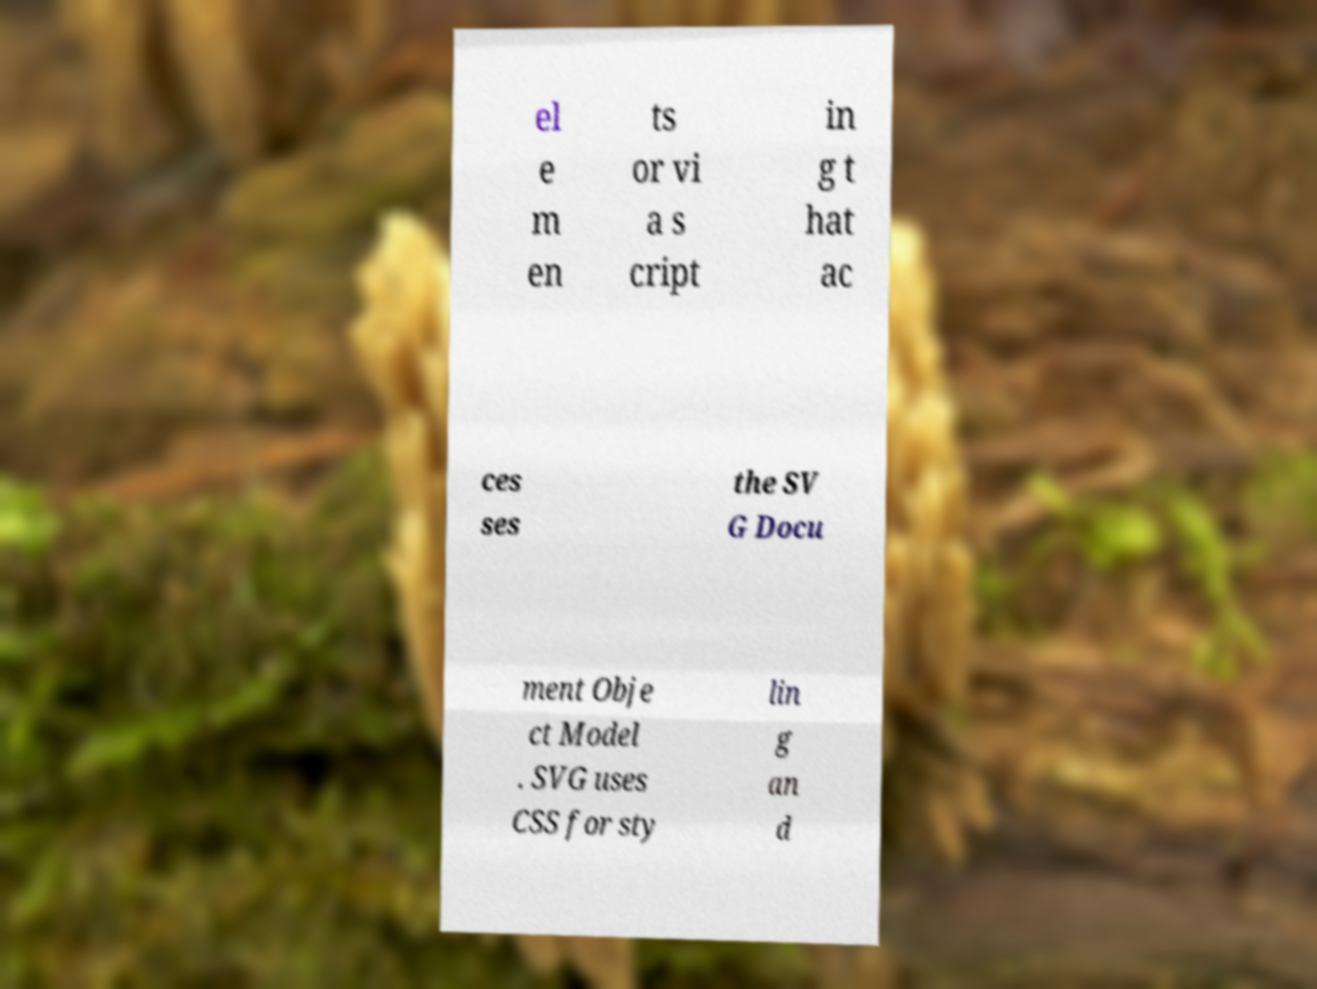Can you accurately transcribe the text from the provided image for me? el e m en ts or vi a s cript in g t hat ac ces ses the SV G Docu ment Obje ct Model . SVG uses CSS for sty lin g an d 